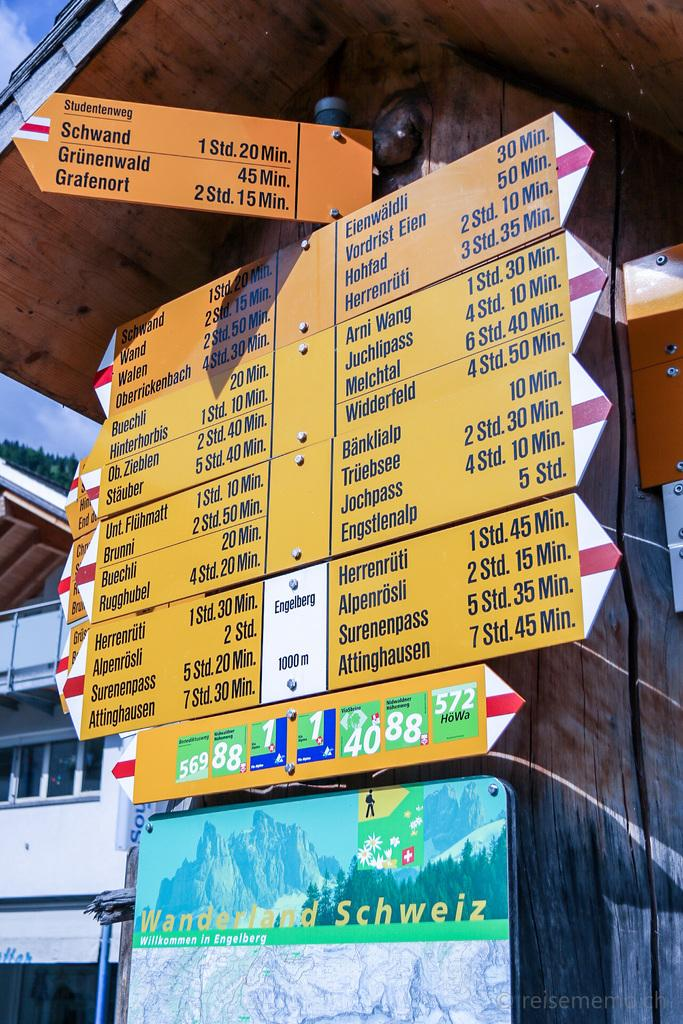What is placed on the wall in the center of the image? There are boards placed on the wall in the center of the image. What structure can be seen on the left side of the image? There is a building on the left side of the image. What is visible in the background of the image? The sky is visible in the background of the image. How many feet are visible on the building in the image? There are no feet visible on the building in the image. What discovery was made by the person in the image? There is no person present in the image, so no discovery can be observed. 